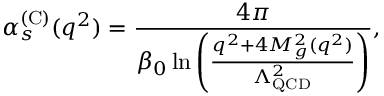Convert formula to latex. <formula><loc_0><loc_0><loc_500><loc_500>\alpha _ { s } ^ { ( C ) } ( q ^ { 2 } ) = \frac { 4 \pi } { \beta _ { 0 } \ln \left ( \frac { q ^ { 2 } + 4 M _ { g } ^ { 2 } ( q ^ { 2 } ) } { \Lambda _ { Q C D } ^ { 2 } } \right ) } ,</formula> 